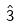Convert formula to latex. <formula><loc_0><loc_0><loc_500><loc_500>\hat { 3 }</formula> 